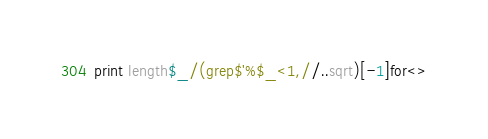<code> <loc_0><loc_0><loc_500><loc_500><_Perl_>print length$_/(grep$'%$_<1,//..sqrt)[-1]for<></code> 